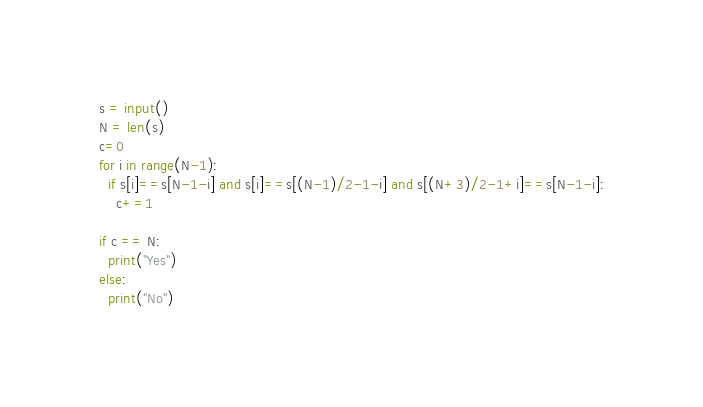<code> <loc_0><loc_0><loc_500><loc_500><_Python_>s = input()
N = len(s)
c=0
for i in range(N-1):
  if s[i]==s[N-1-i] and s[i]==s[(N-1)/2-1-i] and s[(N+3)/2-1+i]==s[N-1-i]:
    c+=1
    
if c == N:
  print("Yes")
else:
  print("No")
</code> 